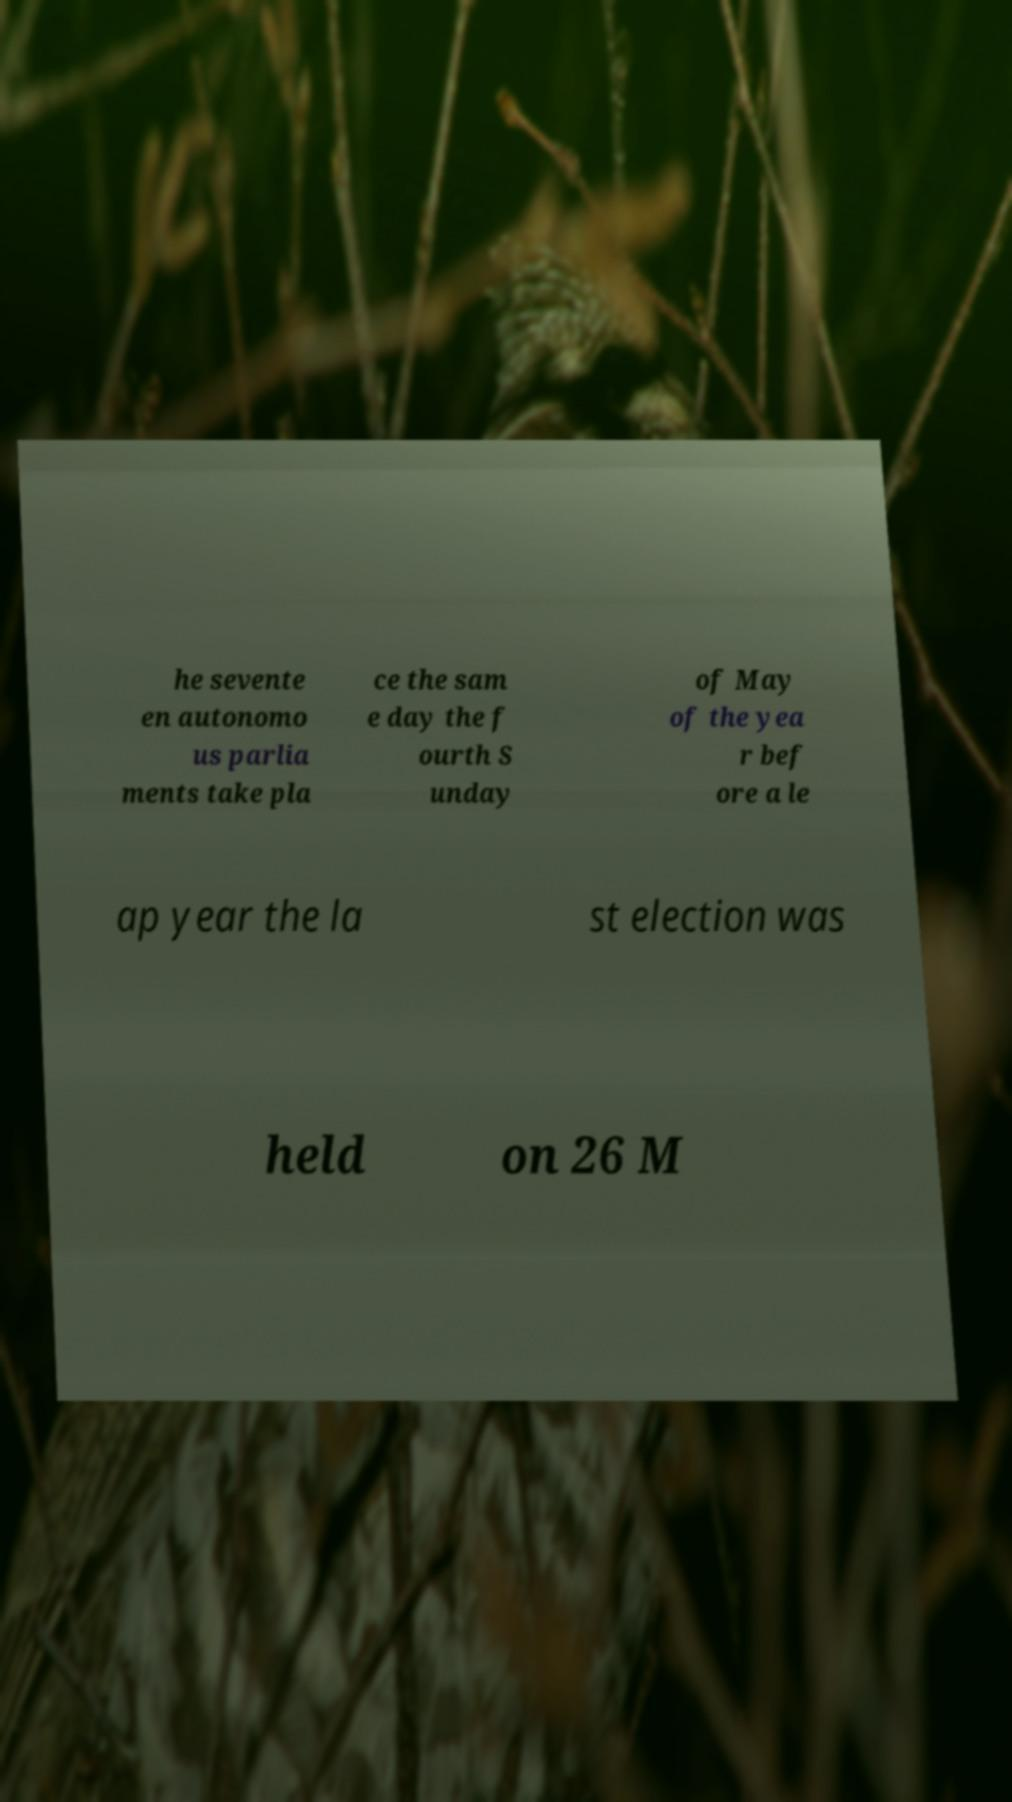Could you assist in decoding the text presented in this image and type it out clearly? he sevente en autonomo us parlia ments take pla ce the sam e day the f ourth S unday of May of the yea r bef ore a le ap year the la st election was held on 26 M 